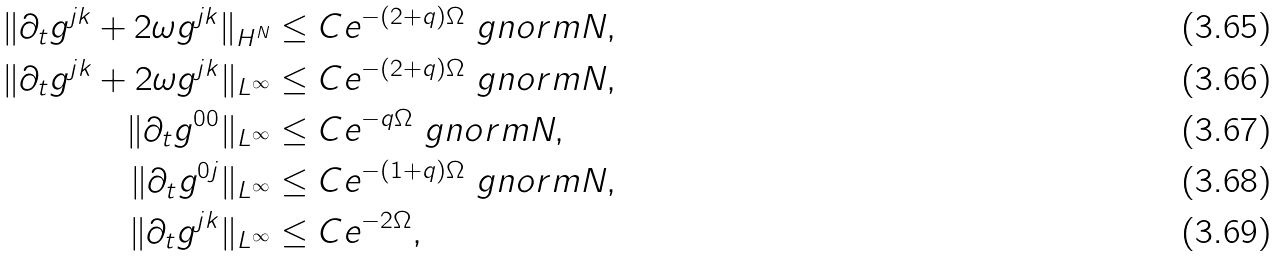Convert formula to latex. <formula><loc_0><loc_0><loc_500><loc_500>\| \partial _ { t } g ^ { j k } + 2 \omega g ^ { j k } \| _ { H ^ { N } } & \leq C e ^ { - ( 2 + q ) \Omega } \ g n o r m { N } , \\ \| \partial _ { t } g ^ { j k } + 2 \omega g ^ { j k } \| _ { L ^ { \infty } } & \leq C e ^ { - ( 2 + q ) \Omega } \ g n o r m { N } , \\ \| \partial _ { t } g ^ { 0 0 } \| _ { L ^ { \infty } } & \leq C e ^ { - q \Omega } \ g n o r m { N } , \\ \| \partial _ { t } g ^ { 0 j } \| _ { L ^ { \infty } } & \leq C e ^ { - ( 1 + q ) \Omega } \ g n o r m { N } , \\ \| \partial _ { t } g ^ { j k } \| _ { L ^ { \infty } } & \leq C e ^ { - 2 \Omega } ,</formula> 